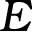Convert formula to latex. <formula><loc_0><loc_0><loc_500><loc_500>E</formula> 